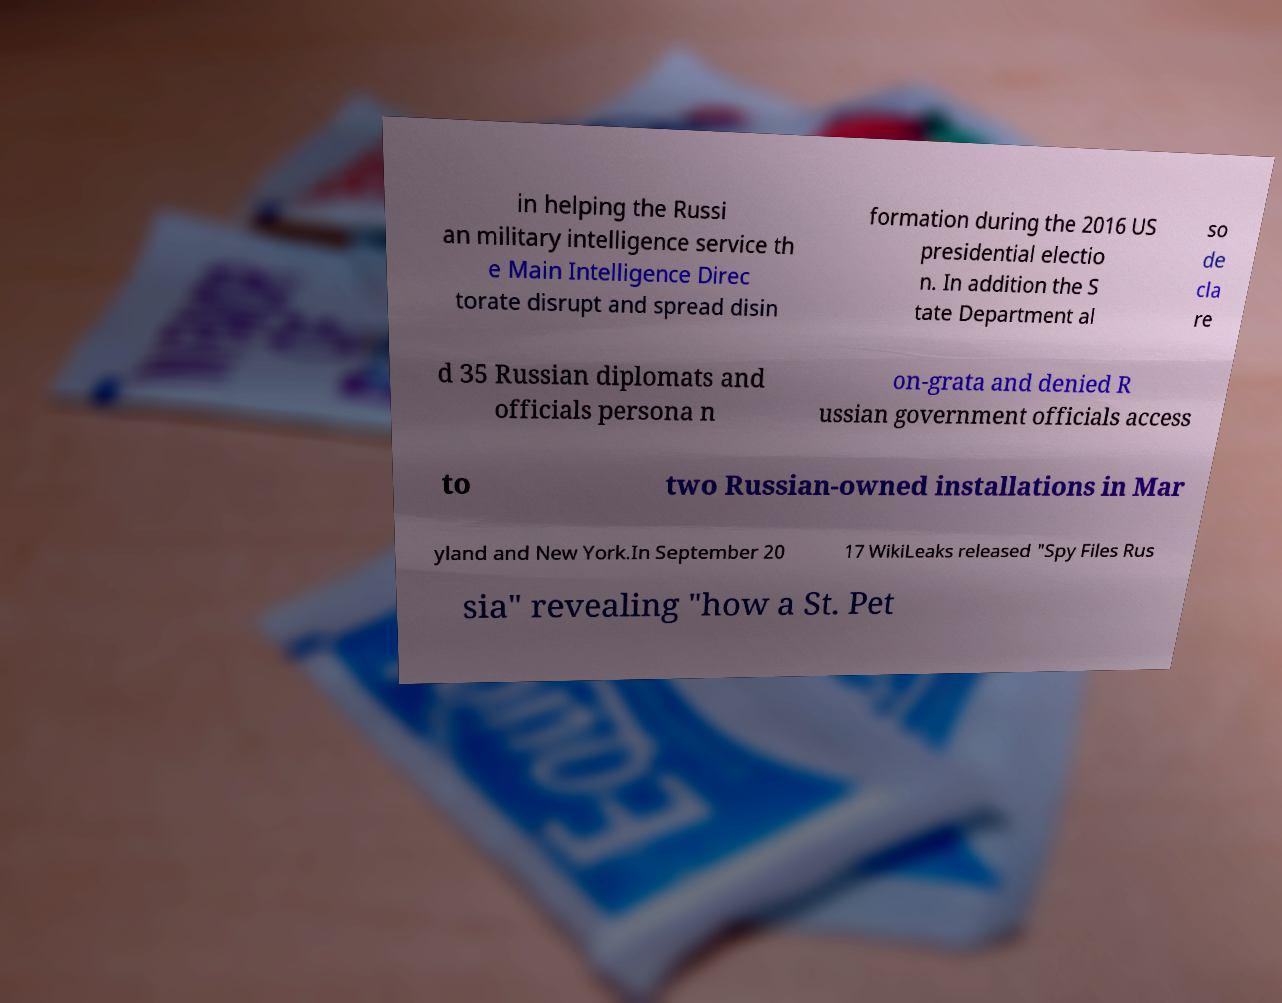Could you extract and type out the text from this image? in helping the Russi an military intelligence service th e Main Intelligence Direc torate disrupt and spread disin formation during the 2016 US presidential electio n. In addition the S tate Department al so de cla re d 35 Russian diplomats and officials persona n on-grata and denied R ussian government officials access to two Russian-owned installations in Mar yland and New York.In September 20 17 WikiLeaks released "Spy Files Rus sia" revealing "how a St. Pet 